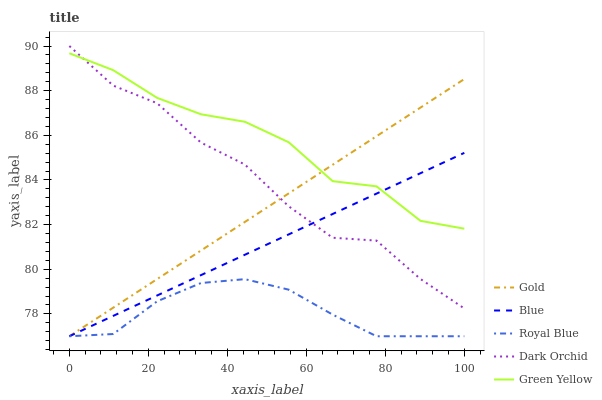Does Green Yellow have the minimum area under the curve?
Answer yes or no. No. Does Royal Blue have the maximum area under the curve?
Answer yes or no. No. Is Royal Blue the smoothest?
Answer yes or no. No. Is Royal Blue the roughest?
Answer yes or no. No. Does Green Yellow have the lowest value?
Answer yes or no. No. Does Green Yellow have the highest value?
Answer yes or no. No. Is Royal Blue less than Green Yellow?
Answer yes or no. Yes. Is Green Yellow greater than Royal Blue?
Answer yes or no. Yes. Does Royal Blue intersect Green Yellow?
Answer yes or no. No. 